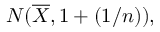Convert formula to latex. <formula><loc_0><loc_0><loc_500><loc_500>N ( { \overline { X } } , 1 + ( 1 / n ) ) ,</formula> 